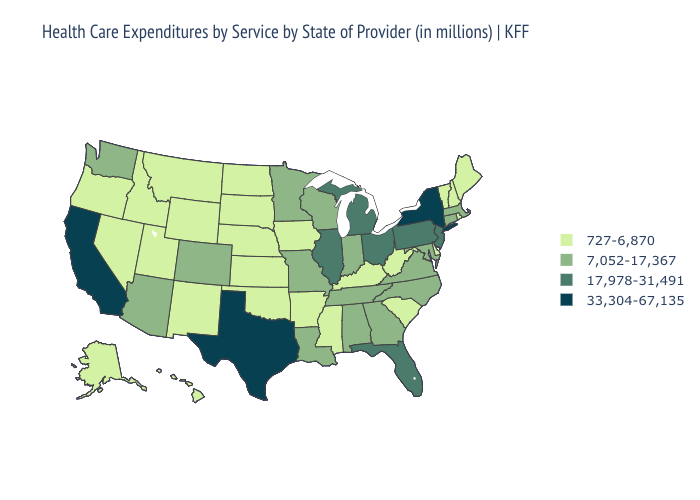Which states have the lowest value in the Northeast?
Write a very short answer. Maine, New Hampshire, Rhode Island, Vermont. Name the states that have a value in the range 17,978-31,491?
Be succinct. Florida, Illinois, Michigan, New Jersey, Ohio, Pennsylvania. Name the states that have a value in the range 33,304-67,135?
Concise answer only. California, New York, Texas. What is the value of New Jersey?
Concise answer only. 17,978-31,491. Among the states that border Kentucky , which have the highest value?
Short answer required. Illinois, Ohio. Which states have the lowest value in the MidWest?
Quick response, please. Iowa, Kansas, Nebraska, North Dakota, South Dakota. Name the states that have a value in the range 727-6,870?
Keep it brief. Alaska, Arkansas, Delaware, Hawaii, Idaho, Iowa, Kansas, Kentucky, Maine, Mississippi, Montana, Nebraska, Nevada, New Hampshire, New Mexico, North Dakota, Oklahoma, Oregon, Rhode Island, South Carolina, South Dakota, Utah, Vermont, West Virginia, Wyoming. What is the value of Nevada?
Give a very brief answer. 727-6,870. What is the value of Rhode Island?
Give a very brief answer. 727-6,870. Name the states that have a value in the range 7,052-17,367?
Be succinct. Alabama, Arizona, Colorado, Connecticut, Georgia, Indiana, Louisiana, Maryland, Massachusetts, Minnesota, Missouri, North Carolina, Tennessee, Virginia, Washington, Wisconsin. Name the states that have a value in the range 727-6,870?
Short answer required. Alaska, Arkansas, Delaware, Hawaii, Idaho, Iowa, Kansas, Kentucky, Maine, Mississippi, Montana, Nebraska, Nevada, New Hampshire, New Mexico, North Dakota, Oklahoma, Oregon, Rhode Island, South Carolina, South Dakota, Utah, Vermont, West Virginia, Wyoming. Name the states that have a value in the range 7,052-17,367?
Answer briefly. Alabama, Arizona, Colorado, Connecticut, Georgia, Indiana, Louisiana, Maryland, Massachusetts, Minnesota, Missouri, North Carolina, Tennessee, Virginia, Washington, Wisconsin. Among the states that border Arkansas , which have the highest value?
Keep it brief. Texas. Among the states that border Arizona , does Nevada have the lowest value?
Write a very short answer. Yes. What is the highest value in states that border Delaware?
Be succinct. 17,978-31,491. 